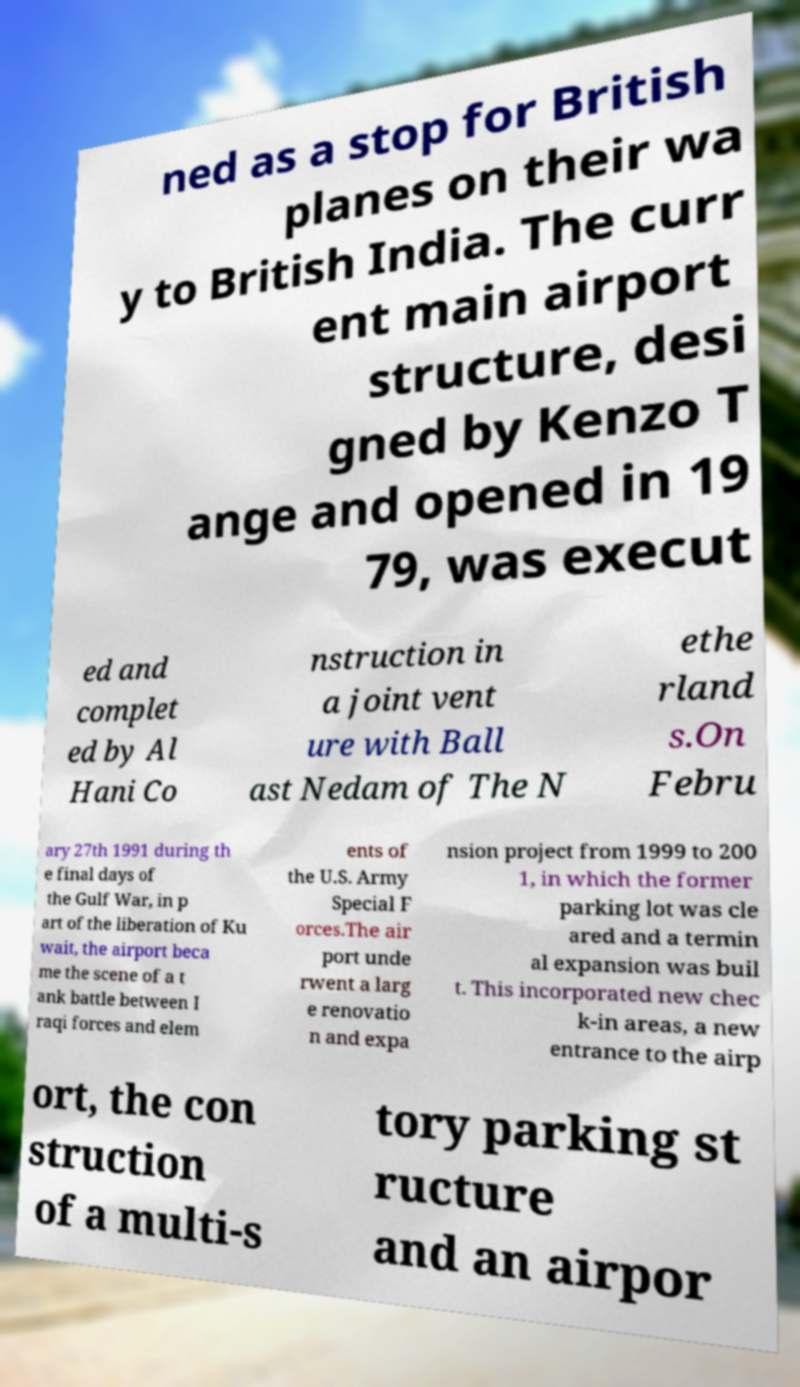Please identify and transcribe the text found in this image. ned as a stop for British planes on their wa y to British India. The curr ent main airport structure, desi gned by Kenzo T ange and opened in 19 79, was execut ed and complet ed by Al Hani Co nstruction in a joint vent ure with Ball ast Nedam of The N ethe rland s.On Febru ary 27th 1991 during th e final days of the Gulf War, in p art of the liberation of Ku wait, the airport beca me the scene of a t ank battle between I raqi forces and elem ents of the U.S. Army Special F orces.The air port unde rwent a larg e renovatio n and expa nsion project from 1999 to 200 1, in which the former parking lot was cle ared and a termin al expansion was buil t. This incorporated new chec k-in areas, a new entrance to the airp ort, the con struction of a multi-s tory parking st ructure and an airpor 